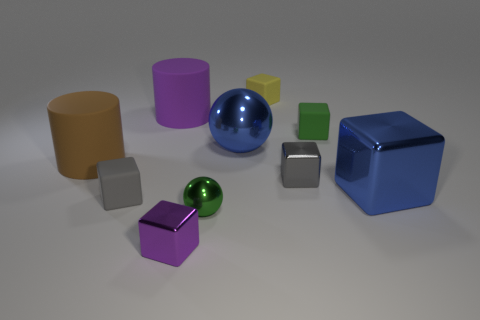Subtract all blue metal blocks. How many blocks are left? 5 Subtract 3 cubes. How many cubes are left? 3 Subtract all balls. How many objects are left? 8 Subtract all yellow cylinders. How many gray cubes are left? 2 Subtract all blue blocks. How many blocks are left? 5 Subtract all yellow cylinders. Subtract all purple blocks. How many cylinders are left? 2 Subtract all tiny green metallic spheres. Subtract all tiny purple objects. How many objects are left? 8 Add 9 tiny green blocks. How many tiny green blocks are left? 10 Add 7 tiny cyan metal cylinders. How many tiny cyan metal cylinders exist? 7 Subtract 1 purple cylinders. How many objects are left? 9 